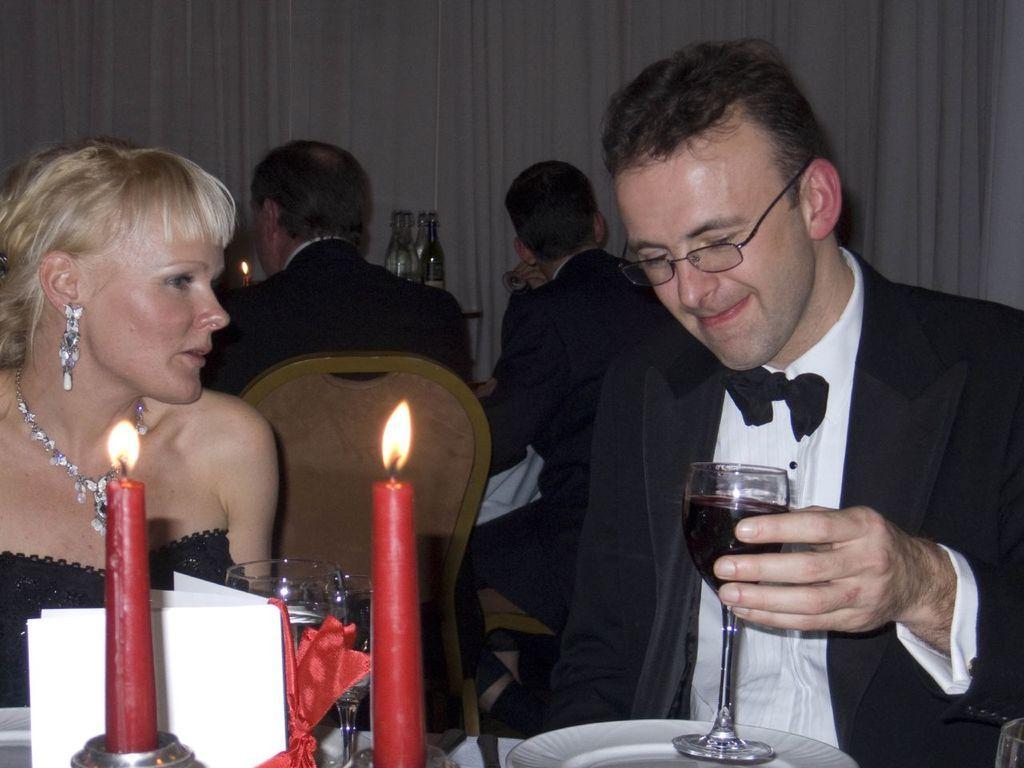Can you describe this image briefly? In the image we can see four persons were sitting on the chair. In front on the right side we can see man holding wine glass and he is smiling. Coming to the left the woman she is also smiling. In front we can see candles on the table. And back of them we can see curtain. 